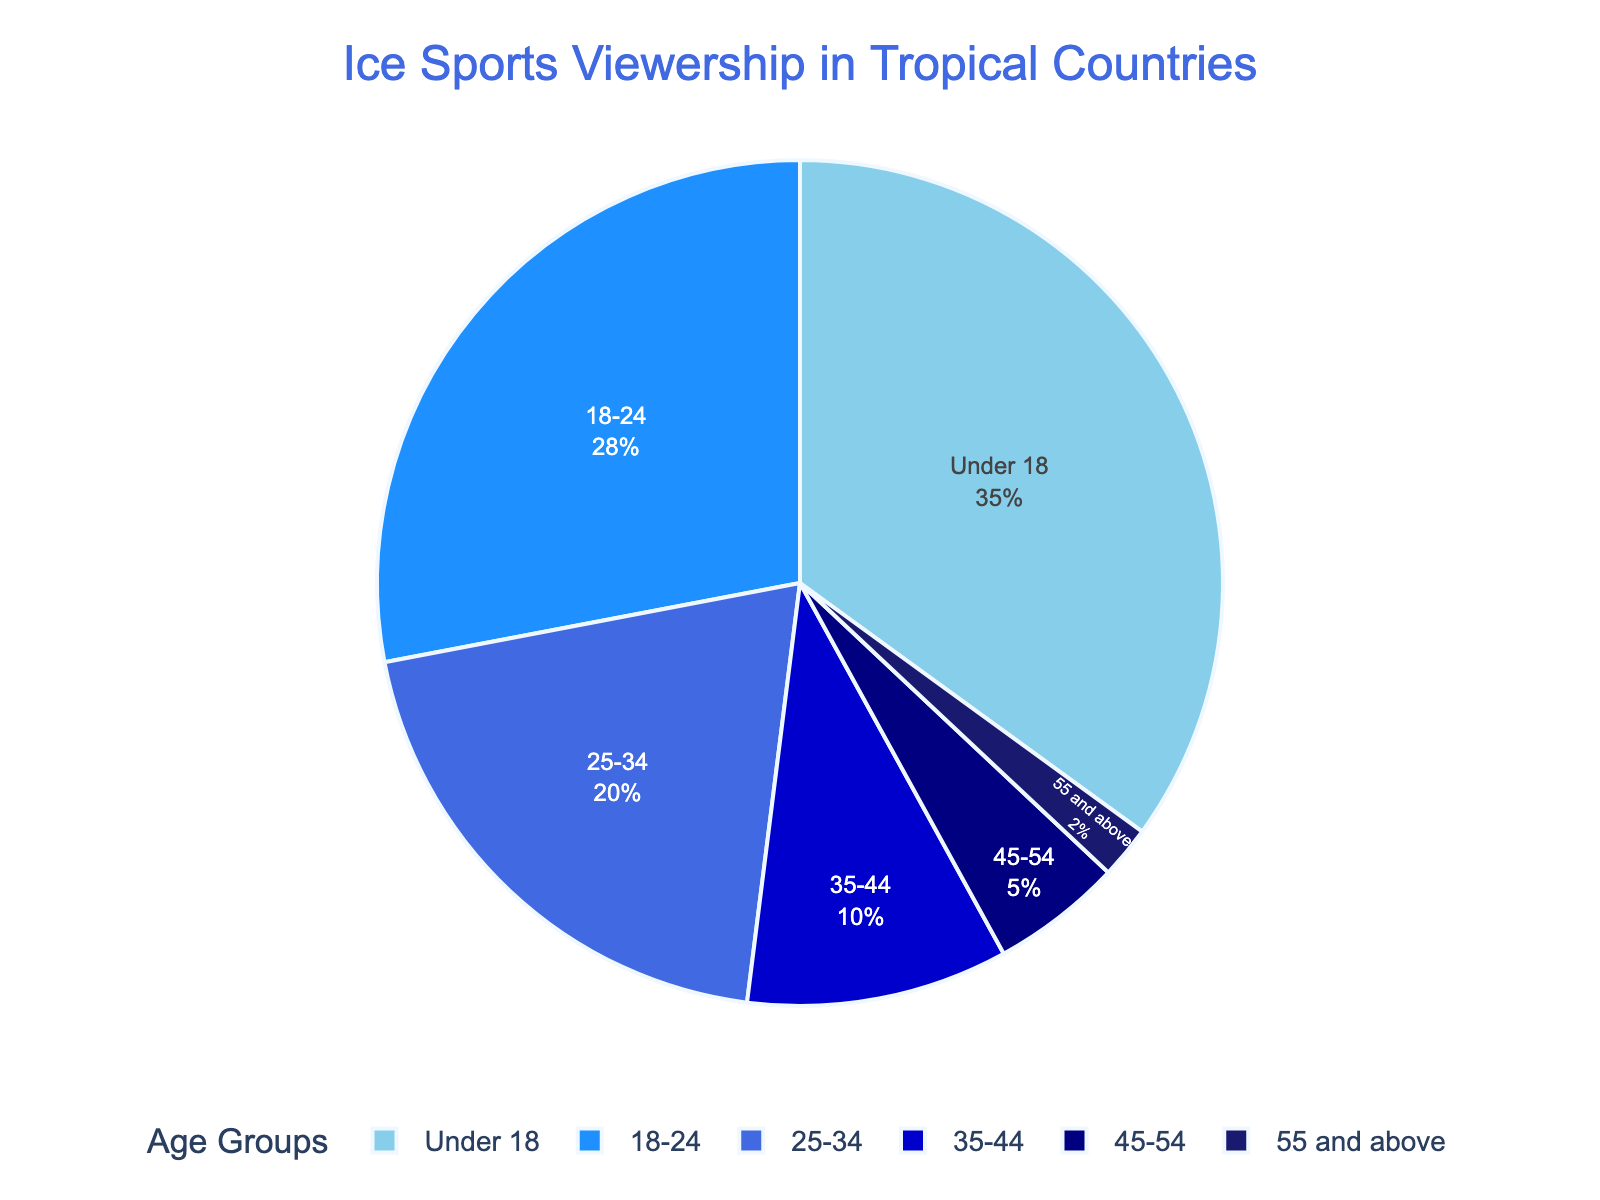Which age group has the largest percentage of ice sports viewership? The chart shows that the 'Under 18' age group has the largest slice.
Answer: Under 18 How many age groups have a viewership percentage of below 10%? By observing the chart, the age groups '35-44', '45-54', and '55 and above' each have slices that are below 10%. That's a total of 3 age groups.
Answer: 3 What is the total percentage of ice sports viewership for age groups 25-34 and above? The percentages for the age groups '25-34', '35-44', '45-54', and '55 and above' are 20%, 10%, 5%, and 2% respectively. Adding these up: 20 + 10 + 5 + 2 = 37%.
Answer: 37% Which age group has a slice colored with a darker blue compared to the others? The darkest blue color in the chart is assigned to the '55 and above' age group.
Answer: 55 and above How much larger is the viewership percentage for 'Under 18' compared to '18-24'? The 'Under 18' age group has 35% and the '18-24' age group has 28%. The difference is 35 - 28 = 7%.
Answer: 7% What fraction of the total viewership is contributed by age groups 45-54 and 55 and above combined? Adding the percentages of '45-54' (5%) and '55 and above' (2%) gives us 5 + 2 = 7%. The fraction is 7/100 = 7%.
Answer: 7% Compare the percentages of viewership for 'Under 18' and '25-34'. Which one is higher and by how much? The 'Under 18' age group has 35% while '25-34' has 20%. Therefore, 'Under 18' is 35 - 20 = 15% higher.
Answer: 15% higher Which age group contributes the least to ice sports viewership? The chart shows that the smallest slice corresponds to the '55 and above' age group with 2%.
Answer: 55 and above 